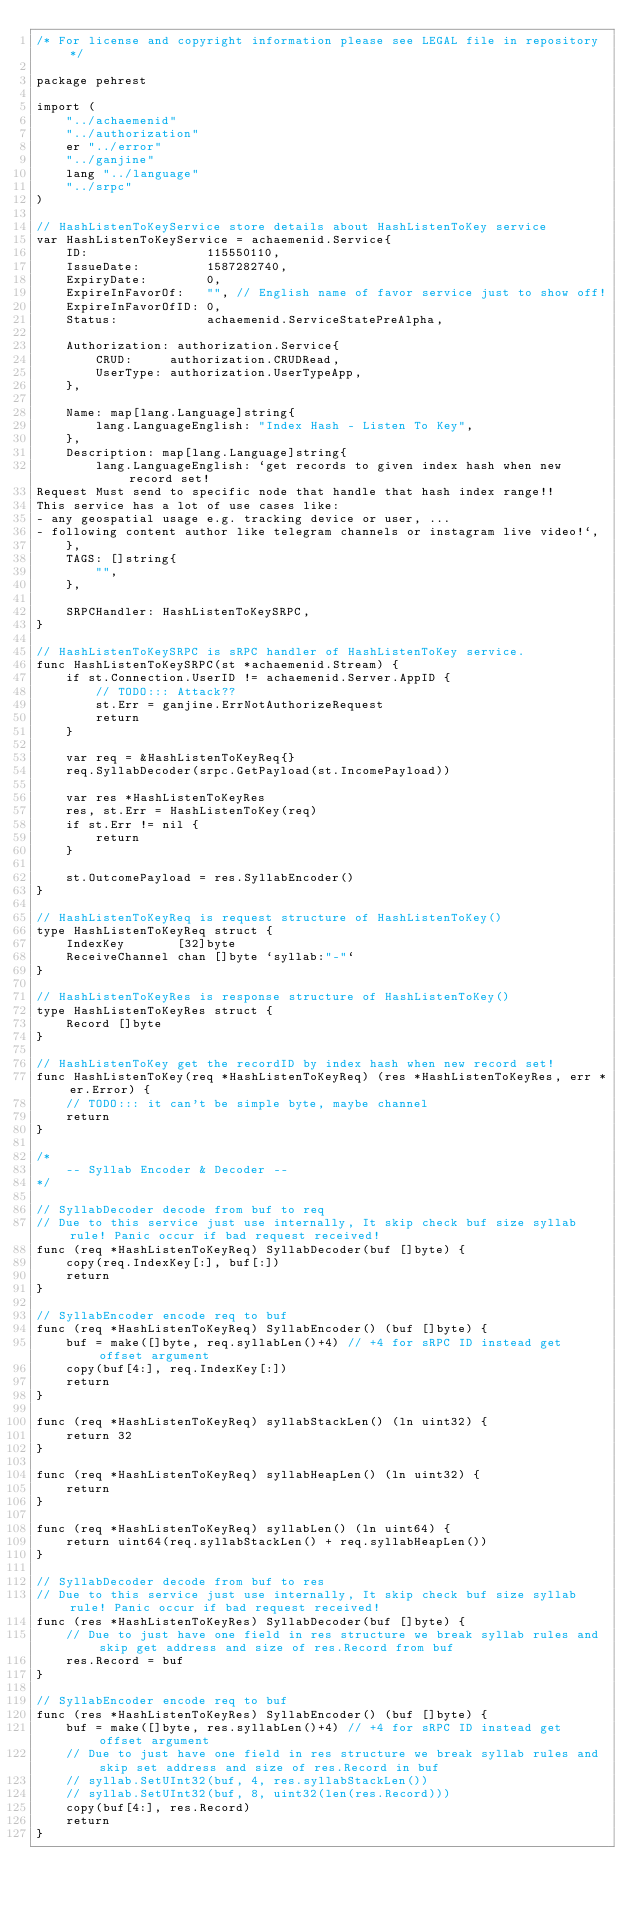Convert code to text. <code><loc_0><loc_0><loc_500><loc_500><_Go_>/* For license and copyright information please see LEGAL file in repository */

package pehrest

import (
	"../achaemenid"
	"../authorization"
	er "../error"
	"../ganjine"
	lang "../language"
	"../srpc"
)

// HashListenToKeyService store details about HashListenToKey service
var HashListenToKeyService = achaemenid.Service{
	ID:                115550110,
	IssueDate:         1587282740,
	ExpiryDate:        0,
	ExpireInFavorOf:   "", // English name of favor service just to show off!
	ExpireInFavorOfID: 0,
	Status:            achaemenid.ServiceStatePreAlpha,

	Authorization: authorization.Service{
		CRUD:     authorization.CRUDRead,
		UserType: authorization.UserTypeApp,
	},

	Name: map[lang.Language]string{
		lang.LanguageEnglish: "Index Hash - Listen To Key",
	},
	Description: map[lang.Language]string{
		lang.LanguageEnglish: `get records to given index hash when new record set!
Request Must send to specific node that handle that hash index range!!
This service has a lot of use cases like:
- any geospatial usage e.g. tracking device or user, ...
- following content author like telegram channels or instagram live video!`,
	},
	TAGS: []string{
		"",
	},

	SRPCHandler: HashListenToKeySRPC,
}

// HashListenToKeySRPC is sRPC handler of HashListenToKey service.
func HashListenToKeySRPC(st *achaemenid.Stream) {
	if st.Connection.UserID != achaemenid.Server.AppID {
		// TODO::: Attack??
		st.Err = ganjine.ErrNotAuthorizeRequest
		return
	}

	var req = &HashListenToKeyReq{}
	req.SyllabDecoder(srpc.GetPayload(st.IncomePayload))

	var res *HashListenToKeyRes
	res, st.Err = HashListenToKey(req)
	if st.Err != nil {
		return
	}

	st.OutcomePayload = res.SyllabEncoder()
}

// HashListenToKeyReq is request structure of HashListenToKey()
type HashListenToKeyReq struct {
	IndexKey       [32]byte
	ReceiveChannel chan []byte `syllab:"-"`
}

// HashListenToKeyRes is response structure of HashListenToKey()
type HashListenToKeyRes struct {
	Record []byte
}

// HashListenToKey get the recordID by index hash when new record set!
func HashListenToKey(req *HashListenToKeyReq) (res *HashListenToKeyRes, err *er.Error) {
	// TODO::: it can't be simple byte, maybe channel
	return
}

/*
	-- Syllab Encoder & Decoder --
*/

// SyllabDecoder decode from buf to req
// Due to this service just use internally, It skip check buf size syllab rule! Panic occur if bad request received!
func (req *HashListenToKeyReq) SyllabDecoder(buf []byte) {
	copy(req.IndexKey[:], buf[:])
	return
}

// SyllabEncoder encode req to buf
func (req *HashListenToKeyReq) SyllabEncoder() (buf []byte) {
	buf = make([]byte, req.syllabLen()+4) // +4 for sRPC ID instead get offset argument
	copy(buf[4:], req.IndexKey[:])
	return
}

func (req *HashListenToKeyReq) syllabStackLen() (ln uint32) {
	return 32
}

func (req *HashListenToKeyReq) syllabHeapLen() (ln uint32) {
	return
}

func (req *HashListenToKeyReq) syllabLen() (ln uint64) {
	return uint64(req.syllabStackLen() + req.syllabHeapLen())
}

// SyllabDecoder decode from buf to res
// Due to this service just use internally, It skip check buf size syllab rule! Panic occur if bad request received!
func (res *HashListenToKeyRes) SyllabDecoder(buf []byte) {
	// Due to just have one field in res structure we break syllab rules and skip get address and size of res.Record from buf
	res.Record = buf
}

// SyllabEncoder encode req to buf
func (res *HashListenToKeyRes) SyllabEncoder() (buf []byte) {
	buf = make([]byte, res.syllabLen()+4) // +4 for sRPC ID instead get offset argument
	// Due to just have one field in res structure we break syllab rules and skip set address and size of res.Record in buf
	// syllab.SetUInt32(buf, 4, res.syllabStackLen())
	// syllab.SetUInt32(buf, 8, uint32(len(res.Record)))
	copy(buf[4:], res.Record)
	return
}
</code> 